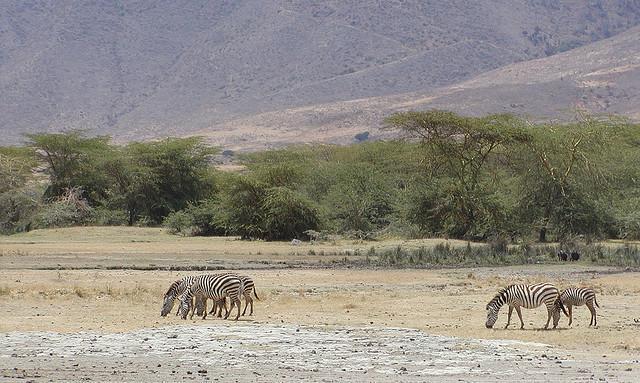How many zebras?
Give a very brief answer. 4. How many people holding umbrellas are in the picture?
Give a very brief answer. 0. 